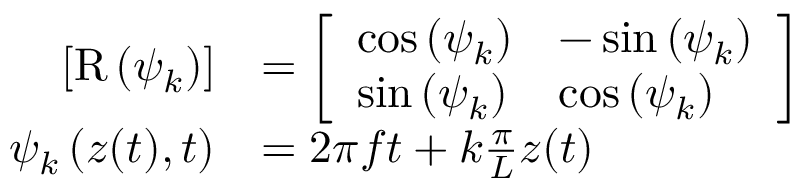Convert formula to latex. <formula><loc_0><loc_0><loc_500><loc_500>\begin{array} { r l } { \left [ R \left ( \psi _ { k } \right ) \right ] } & { = \left [ \begin{array} { l l } { \cos \left ( \psi _ { k } \right ) } & { - \sin \left ( \psi _ { k } \right ) } \\ { \sin \left ( \psi _ { k } \right ) } & { \cos \left ( \psi _ { k } \right ) } \end{array} \right ] } \\ { \psi _ { k } \left ( z ( t ) , t \right ) } & { = 2 \pi f t + k \frac { \pi } { L } z ( t ) } \end{array}</formula> 